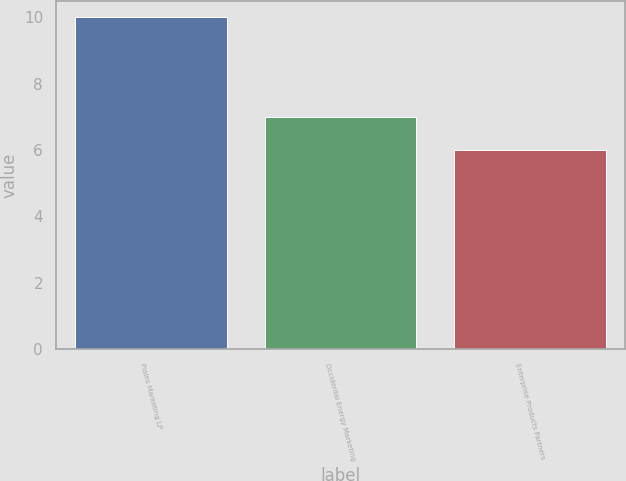<chart> <loc_0><loc_0><loc_500><loc_500><bar_chart><fcel>Plains Marketing LP<fcel>Occidental Energy Marketing<fcel>Enterprise Products Partners<nl><fcel>10<fcel>7<fcel>6<nl></chart> 